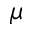<formula> <loc_0><loc_0><loc_500><loc_500>\mu</formula> 